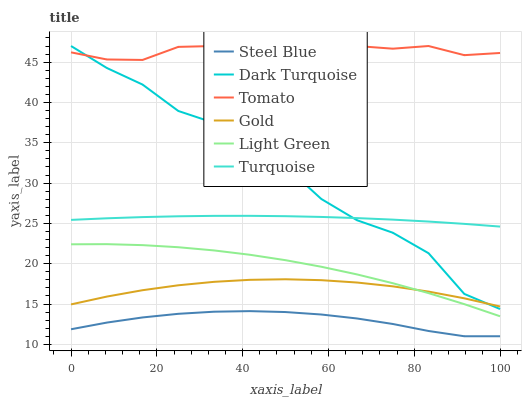Does Steel Blue have the minimum area under the curve?
Answer yes or no. Yes. Does Tomato have the maximum area under the curve?
Answer yes or no. Yes. Does Turquoise have the minimum area under the curve?
Answer yes or no. No. Does Turquoise have the maximum area under the curve?
Answer yes or no. No. Is Turquoise the smoothest?
Answer yes or no. Yes. Is Dark Turquoise the roughest?
Answer yes or no. Yes. Is Gold the smoothest?
Answer yes or no. No. Is Gold the roughest?
Answer yes or no. No. Does Turquoise have the lowest value?
Answer yes or no. No. Does Dark Turquoise have the highest value?
Answer yes or no. Yes. Does Turquoise have the highest value?
Answer yes or no. No. Is Steel Blue less than Dark Turquoise?
Answer yes or no. Yes. Is Tomato greater than Gold?
Answer yes or no. Yes. Does Gold intersect Dark Turquoise?
Answer yes or no. Yes. Is Gold less than Dark Turquoise?
Answer yes or no. No. Is Gold greater than Dark Turquoise?
Answer yes or no. No. Does Steel Blue intersect Dark Turquoise?
Answer yes or no. No. 